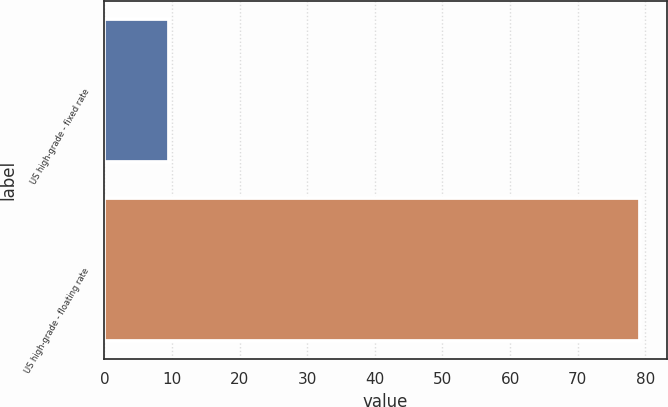Convert chart. <chart><loc_0><loc_0><loc_500><loc_500><bar_chart><fcel>US high-grade - fixed rate<fcel>US high-grade - floating rate<nl><fcel>9.6<fcel>79.2<nl></chart> 